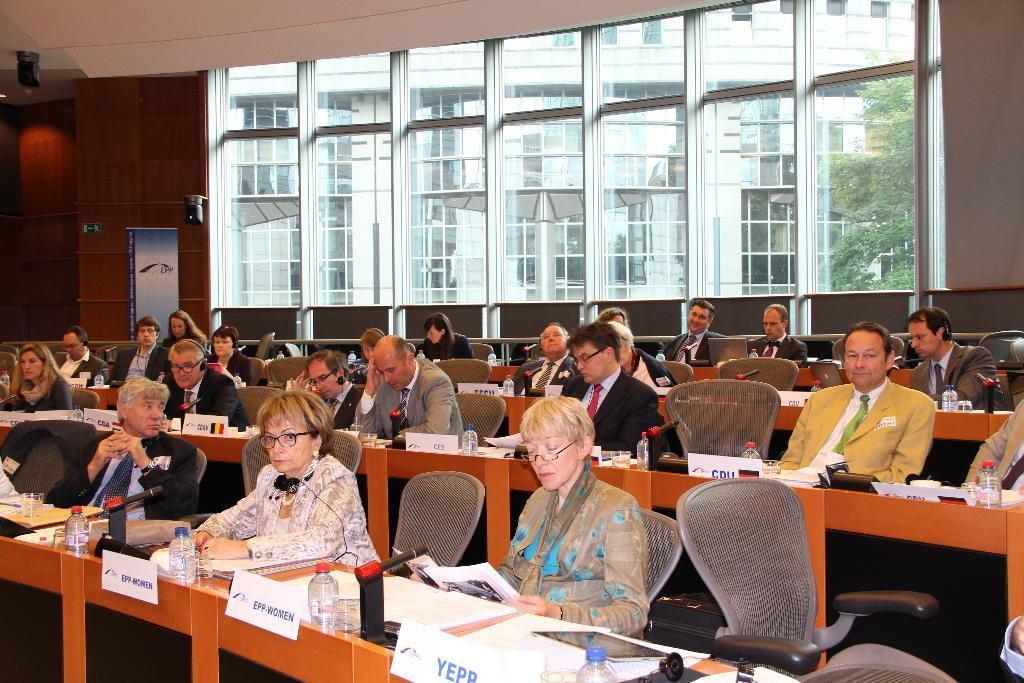What are the people in the image doing? The people in the image are sitting in chairs at tables. How are the tables arranged in the image? The tables are arranged in a row. What can be seen behind the people in the image? There are windows behind the people, and a building is visible in the background through the windows. What type of toy can be seen shaking in the hands of the people in the image? There is no toy present in the image, and no one is shaking anything. 